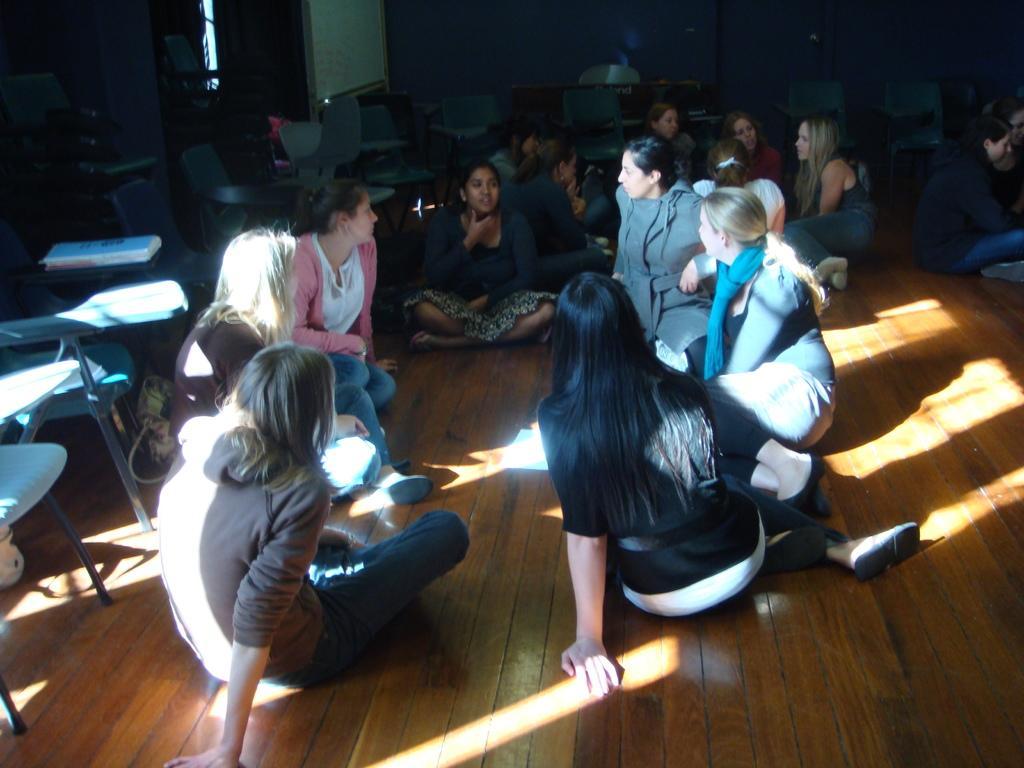Could you give a brief overview of what you see in this image? In this picture I can see few people seated on the floor and I can see chairs and looks like a table in the back. 